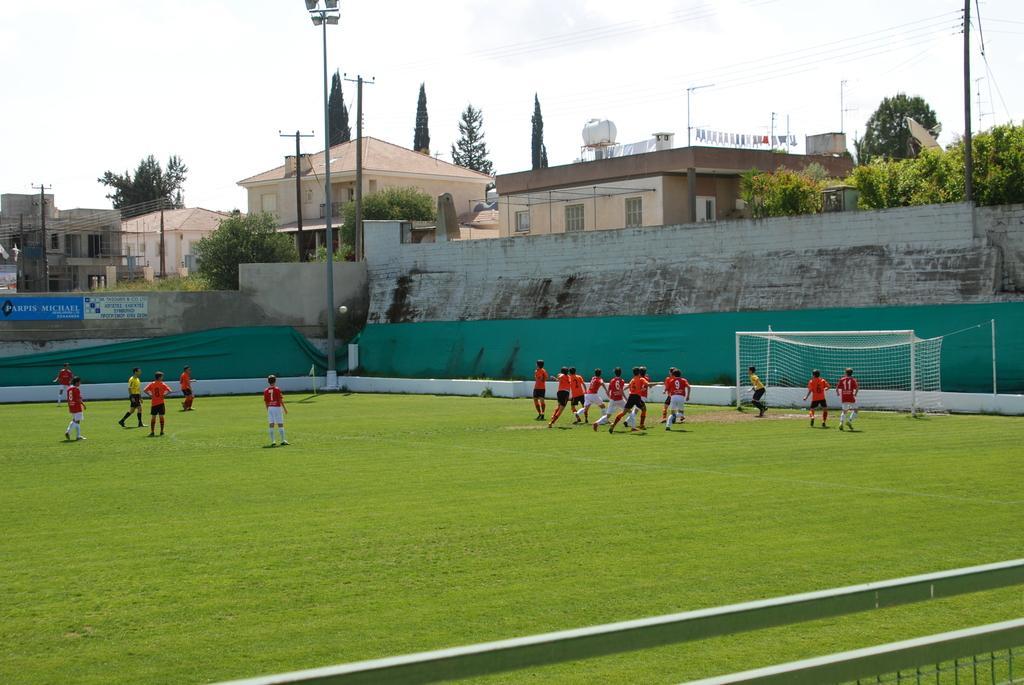Please provide a concise description of this image. In this picture we can see some people playing on the path and behind the people there is a wall, poles with lights, electric poles with cables, trees, buildings. Behind the buildings there is a sky. 